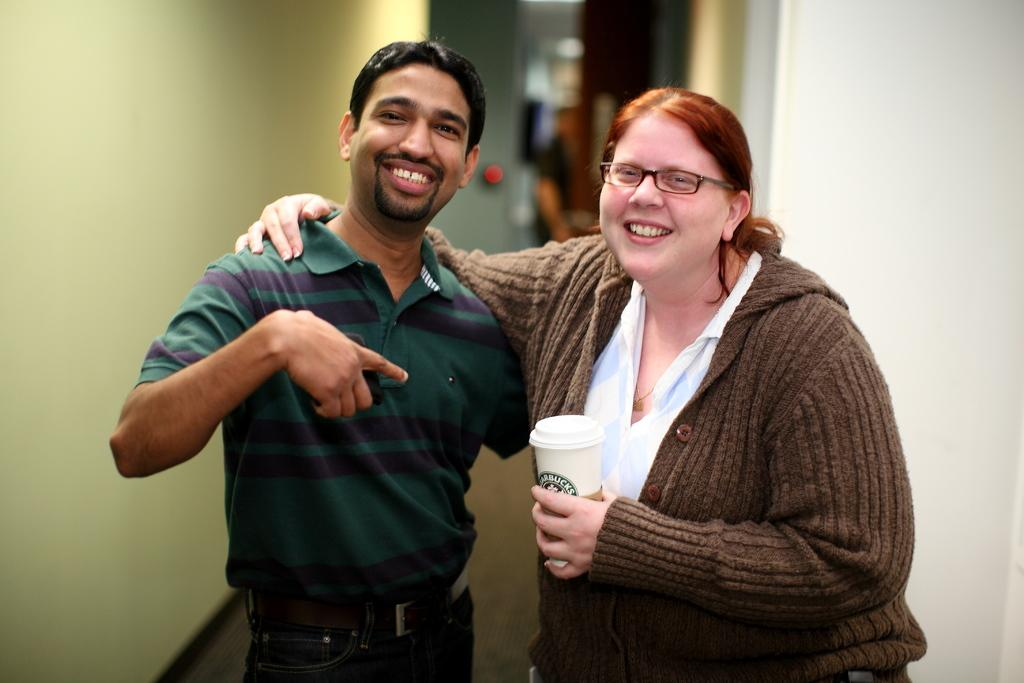How many people are in the image? There are two persons in the image. What is the location of the persons in the image? The persons are between walls. What are the persons wearing in the image? The persons are wearing clothes. Which side of the image does the person holding a cup appear on? The person holding a cup is on the right side of the image. What is the person on the left side of the image doing while sleeping? There is no person sleeping in the image, and the person on the left side is not mentioned in the facts. --- 